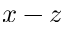<formula> <loc_0><loc_0><loc_500><loc_500>x - z</formula> 